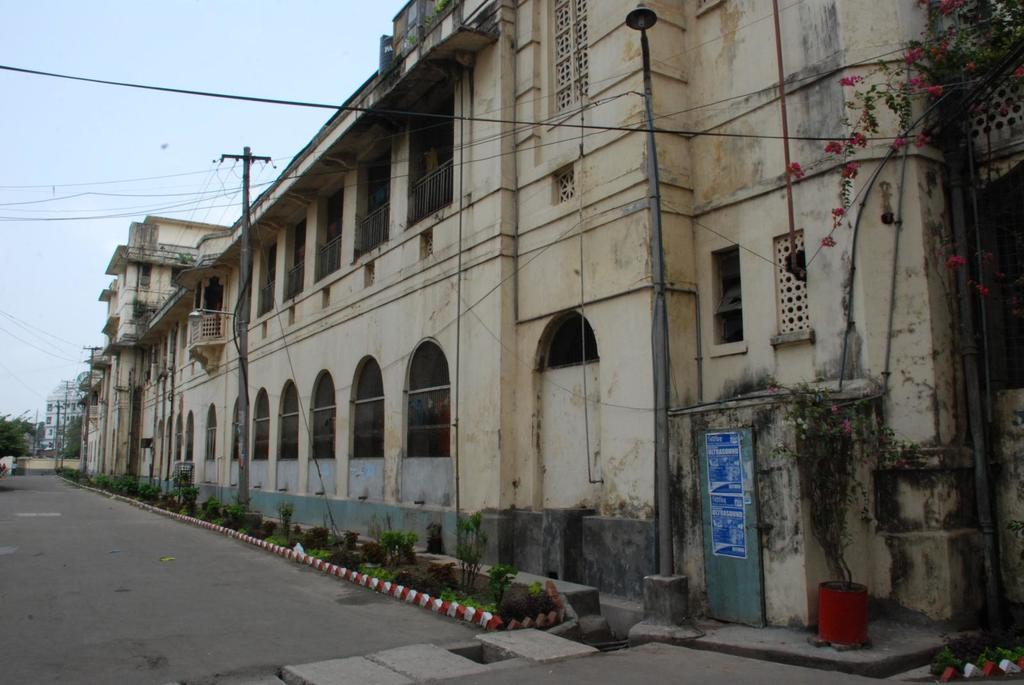What type of structures can be seen in the image? There are buildings in the image. What else is present in the image besides buildings? There are poles, cables, and plants in the image. Can you describe the plants in the image? There are flowers on the right side of the image. What type of bottle can be seen in the image? There is no bottle present in the image. What type of station is visible in the image? There is no station present in the image. 